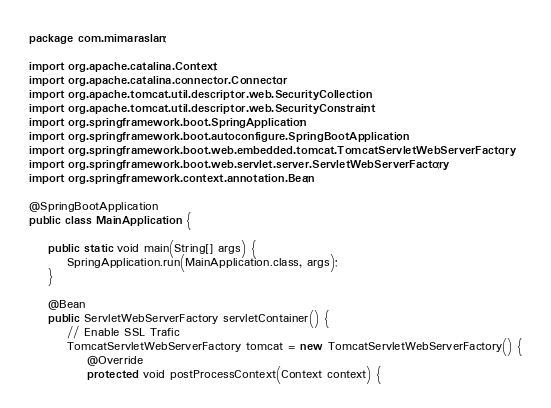Convert code to text. <code><loc_0><loc_0><loc_500><loc_500><_Java_>package com.mimaraslan;

import org.apache.catalina.Context;
import org.apache.catalina.connector.Connector;
import org.apache.tomcat.util.descriptor.web.SecurityCollection;
import org.apache.tomcat.util.descriptor.web.SecurityConstraint;
import org.springframework.boot.SpringApplication;
import org.springframework.boot.autoconfigure.SpringBootApplication;
import org.springframework.boot.web.embedded.tomcat.TomcatServletWebServerFactory;
import org.springframework.boot.web.servlet.server.ServletWebServerFactory;
import org.springframework.context.annotation.Bean;

@SpringBootApplication
public class MainApplication {

	public static void main(String[] args) {
		SpringApplication.run(MainApplication.class, args);
	}

	@Bean
	public ServletWebServerFactory servletContainer() {
		// Enable SSL Trafic
		TomcatServletWebServerFactory tomcat = new TomcatServletWebServerFactory() {
			@Override
			protected void postProcessContext(Context context) {</code> 